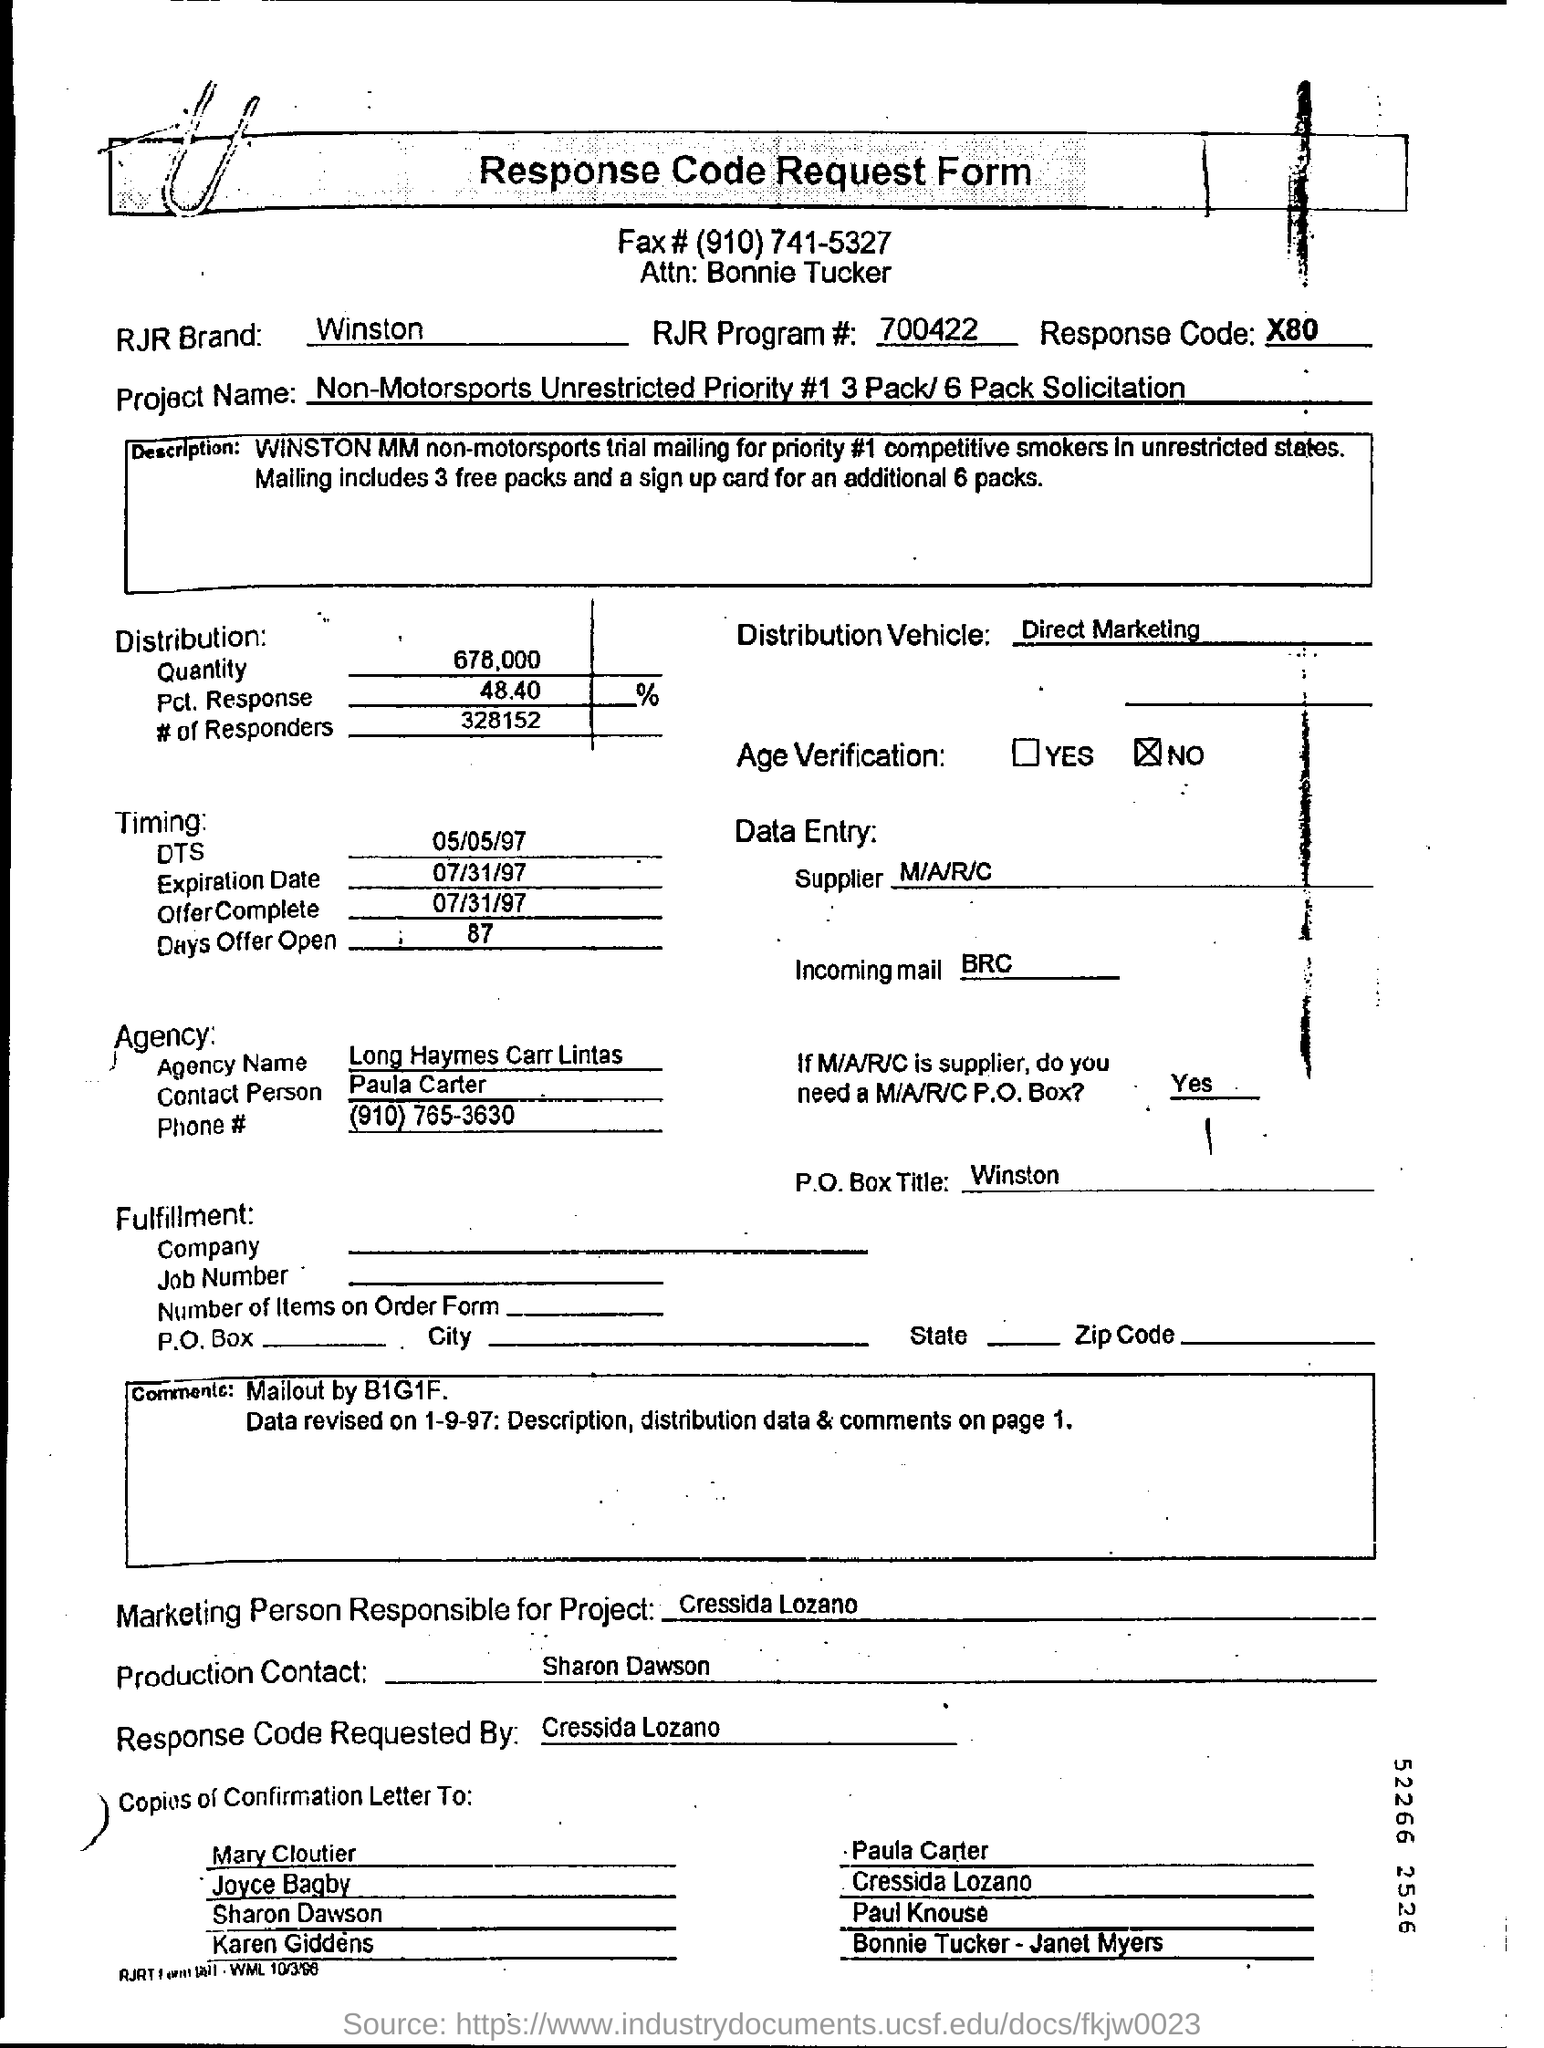What is the Project Name ?
Provide a succinct answer. Non-Motorsports Unrestricted Priority #1 3 Pack/6 Pack Solicitation. What is the RJR Brand ?
Provide a succinct answer. Winston. What is the RJR Program # ?
Provide a succinct answer. 700422. What is the Agency Name?
Your answer should be very brief. Long Haymes Carr Lintas. Who is the contact person in the agency?
Ensure brevity in your answer.  Paula carter. Who is the marketing person responsible for Project?
Provide a short and direct response. Cressida Lozano. Is Age verification required?
Make the answer very short. No. As per the project, how many free packets of cigarettes is to be given?
Give a very brief answer. 3. 